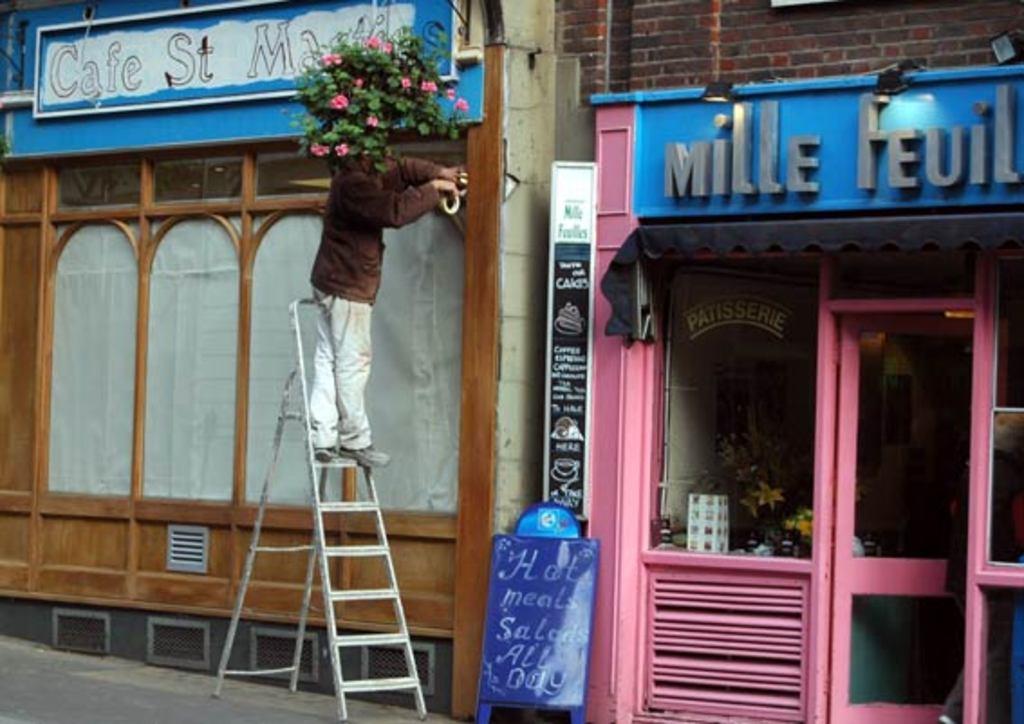What is the name of the pink shop?
Give a very brief answer. Mille feuil. What type of business is on the left?
Your answer should be compact. Cafe. 